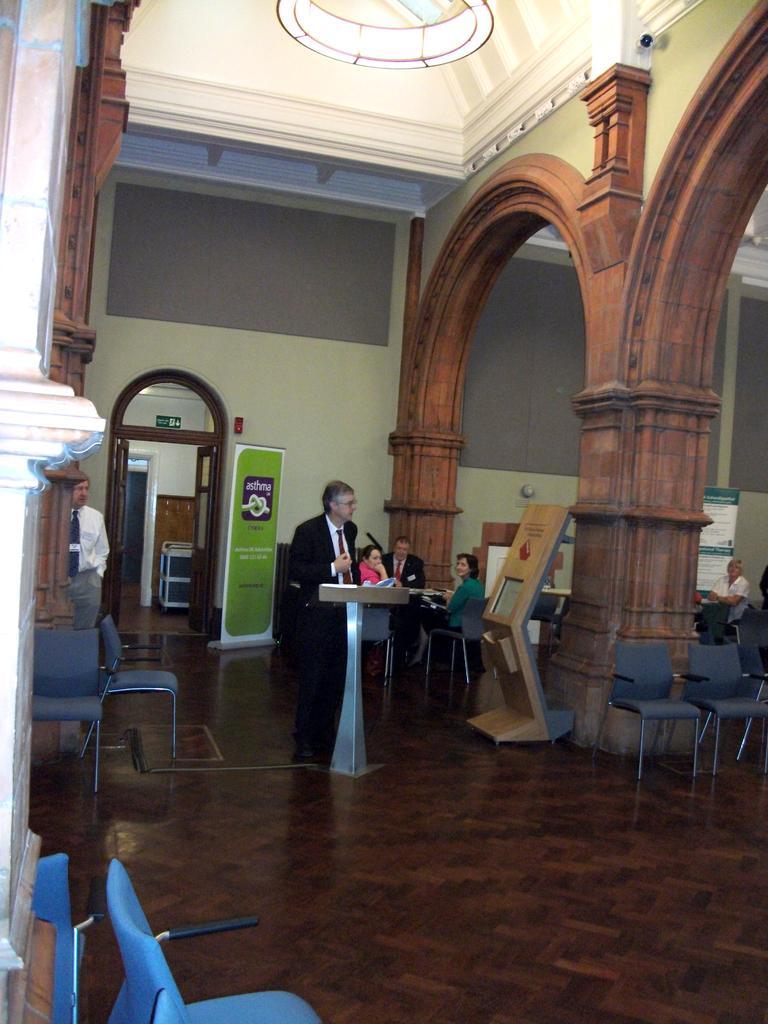Could you give a brief overview of what you see in this image? In the left middle, one person is standing. In the middle is standing in black color suit in front of the standing table and speaking. In the background three persons are sitting on the chair. The pillars are brown in color. The walls are white in color. In the middle bottom, one woman is sitting on the chair. It looks as if the image is taken inside an auditorium hall. 